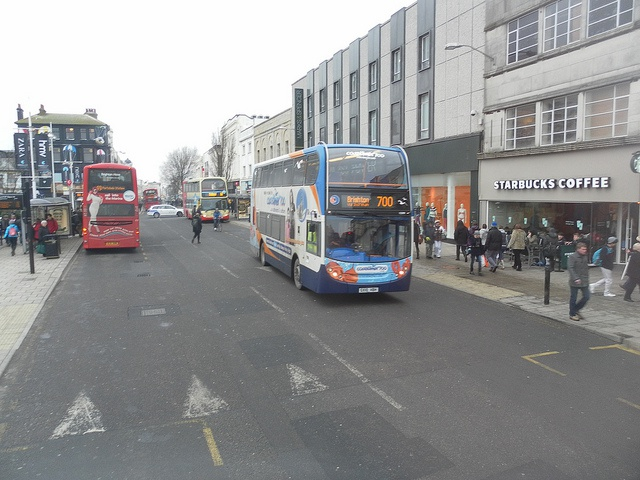Describe the objects in this image and their specific colors. I can see bus in white, gray, darkgray, lightgray, and black tones, bus in white, brown, gray, darkgray, and lightgray tones, people in white, gray, black, darkgray, and maroon tones, bus in white, darkgray, gray, and beige tones, and people in white, gray, and black tones in this image. 